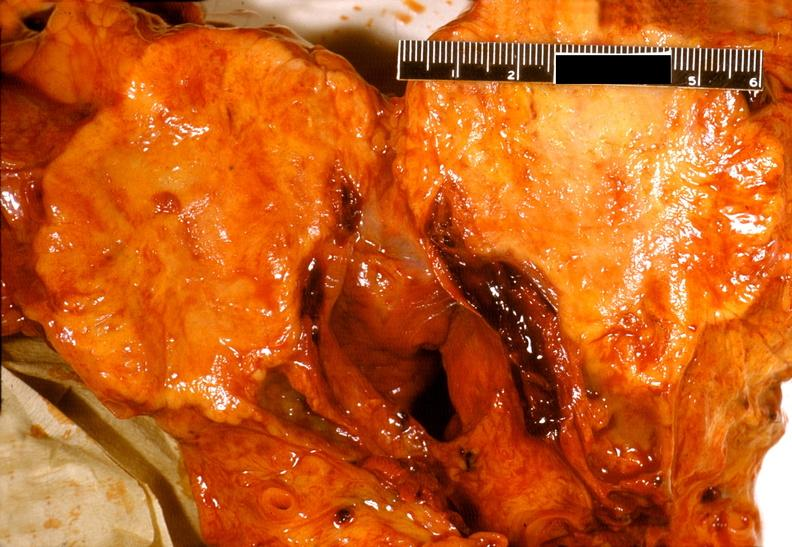does all the fat necrosis show adenocarcinoma, body of pancreas?
Answer the question using a single word or phrase. No 